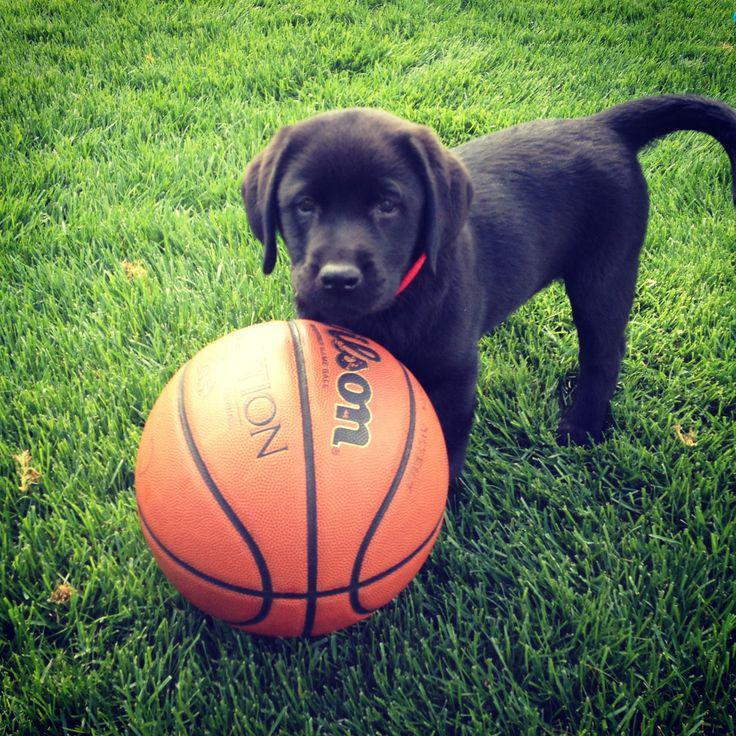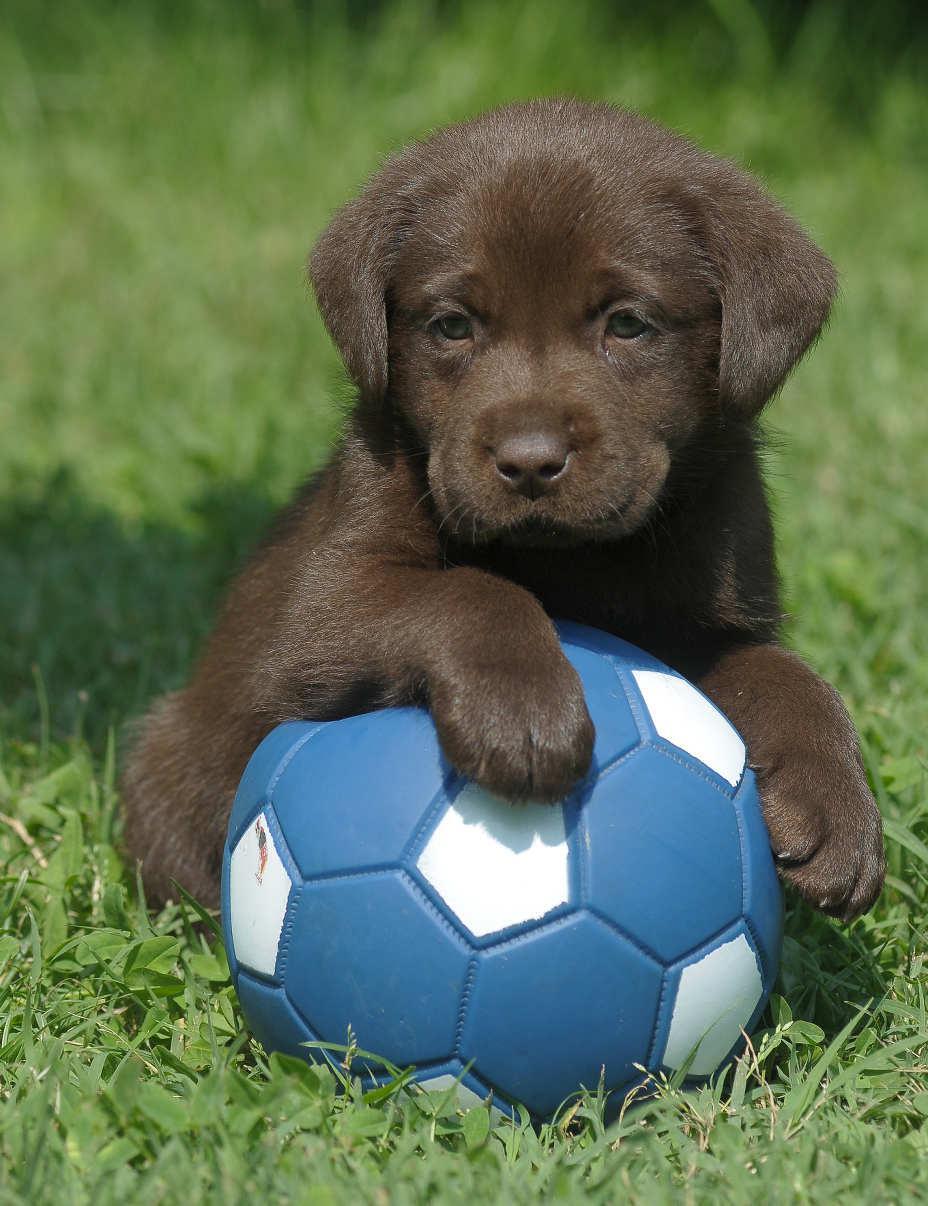The first image is the image on the left, the second image is the image on the right. Analyze the images presented: Is the assertion "Each image shows a puppy posed with a sports ball, and the puppy on the right is sitting behind a soccer ball with one paw atop it." valid? Answer yes or no. Yes. The first image is the image on the left, the second image is the image on the right. For the images shown, is this caption "The dog in the image on the right has one paw resting on a ball." true? Answer yes or no. Yes. 